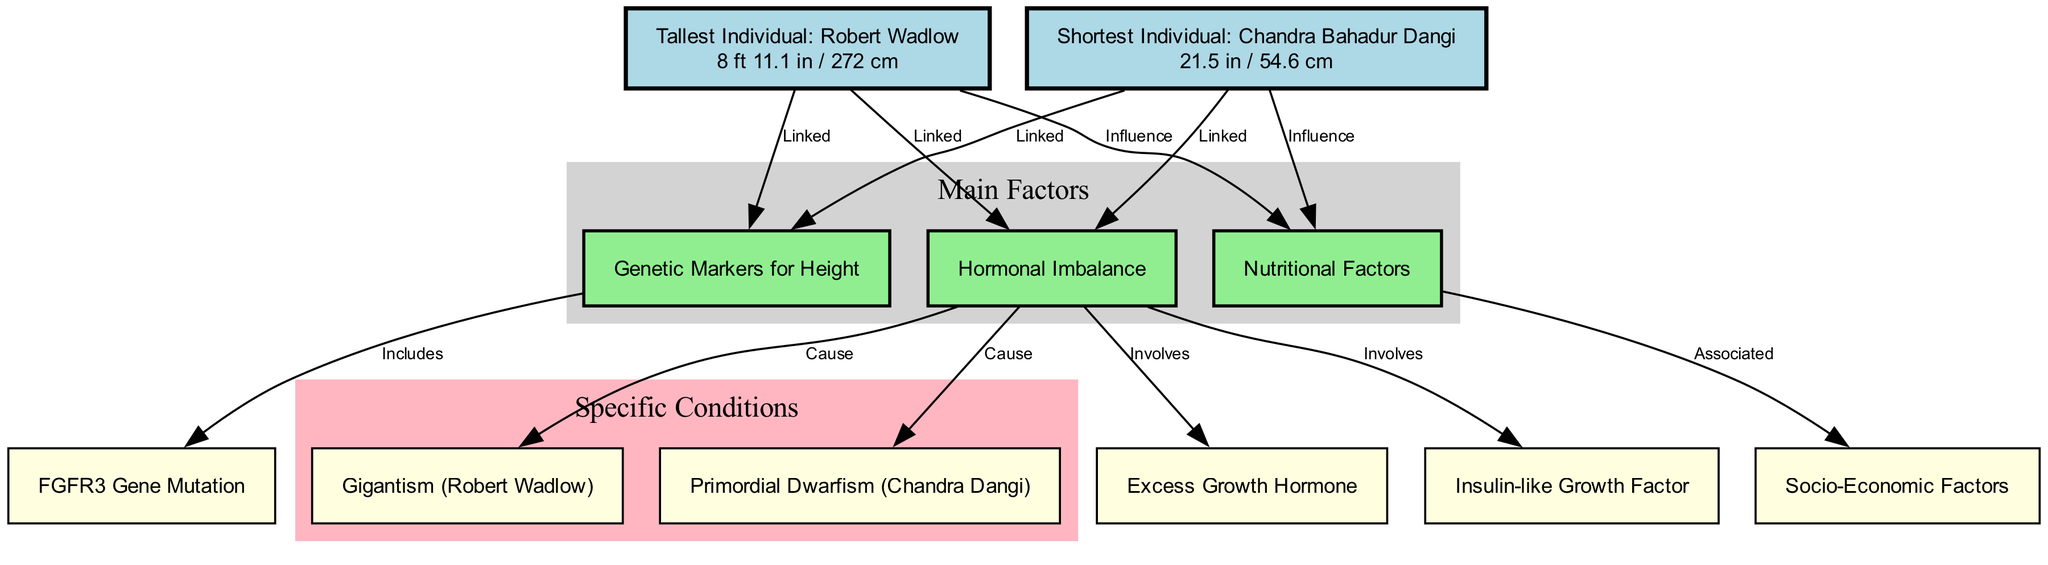What is the height of the tallest individual? The diagram provides the label for the tallest individual, Robert Wadlow, alongside his height, which is specified as 8 ft 11.1 in or 272 cm.
Answer: 8 ft 11.1 in / 272 cm What condition is associated with Robert Wadlow? The diagram indicates a direct link between Robert Wadlow and the "Gigantism" node, showing that gigantism is a specific condition related to his excessive height.
Answer: Gigantism What is the height of the shortest individual? The diagram provides the label for the shortest individual, Chandra Bahadur Dangi, with his height detailed as 21.5 in or 54.6 cm.
Answer: 21.5 in / 54.6 cm What genetic marker is involved in height? The diagram identifies "Genetic Markers for Height" as a central node that connects both the tallest and shortest individuals, indicating this is a primary factor in height.
Answer: Genetic Markers for Height Which hormone is linked to hormonal imbalance? The diagram shows that "Excess Growth Hormone" is directly related to hormonal imbalance, as indicated by the connection labeled "Involves."
Answer: Excess Growth Hormone How do nutrition factors relate to socioeconomic factors? The diagram shows a connection between "Nutrition Factors" and "Socio-Economic Factors," where nutrition factors are associated with socioeconomic conditions, suggesting that better nutrition may stem from higher socioeconomic status.
Answer: Associated What condition is linked to hormonal imbalance for the shortest individual? The diagram indicates that "Primordial Dwarfism" is linked to hormonal imbalance, directly relating to the condition of Chandra Dangi, who is the shortest individual.
Answer: Primordial Dwarfism Which genetic marker mutation is specifically mentioned? In the diagram, the "FGFR3 Gene Mutation" is included under the node detailing genetic markers for height, indicating its relevance in height attributes.
Answer: FGFR3 Gene Mutation How many main factors are identified in the diagram? The diagram shows three primary factors: "Genetic Markers for Height," "Hormonal Imbalance," and "Nutritional Factors," which are grouped together under the cluster labeled 'Main Factors.'
Answer: 3 